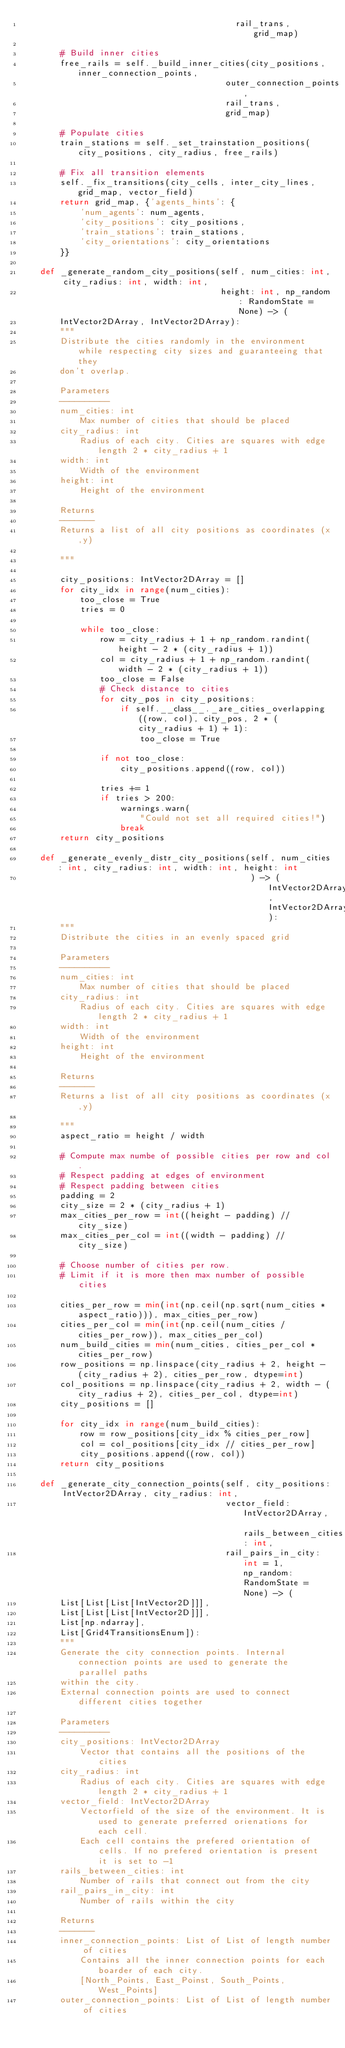<code> <loc_0><loc_0><loc_500><loc_500><_Python_>                                           rail_trans, grid_map)

        # Build inner cities
        free_rails = self._build_inner_cities(city_positions, inner_connection_points,
                                         outer_connection_points,
                                         rail_trans,
                                         grid_map)

        # Populate cities
        train_stations = self._set_trainstation_positions(city_positions, city_radius, free_rails)

        # Fix all transition elements
        self._fix_transitions(city_cells, inter_city_lines, grid_map, vector_field)
        return grid_map, {'agents_hints': {
            'num_agents': num_agents,
            'city_positions': city_positions,
            'train_stations': train_stations,
            'city_orientations': city_orientations
        }}

    def _generate_random_city_positions(self, num_cities: int, city_radius: int, width: int,
                                        height: int, np_random: RandomState = None) -> (
        IntVector2DArray, IntVector2DArray):
        """
        Distribute the cities randomly in the environment while respecting city sizes and guaranteeing that they
        don't overlap.

        Parameters
        ----------
        num_cities: int
            Max number of cities that should be placed
        city_radius: int
            Radius of each city. Cities are squares with edge length 2 * city_radius + 1
        width: int
            Width of the environment
        height: int
            Height of the environment

        Returns
        -------
        Returns a list of all city positions as coordinates (x,y)

        """

        city_positions: IntVector2DArray = []
        for city_idx in range(num_cities):
            too_close = True
            tries = 0

            while too_close:
                row = city_radius + 1 + np_random.randint(height - 2 * (city_radius + 1))
                col = city_radius + 1 + np_random.randint(width - 2 * (city_radius + 1))
                too_close = False
                # Check distance to cities
                for city_pos in city_positions:
                    if self.__class__._are_cities_overlapping((row, col), city_pos, 2 * (city_radius + 1) + 1):
                        too_close = True

                if not too_close:
                    city_positions.append((row, col))

                tries += 1
                if tries > 200:
                    warnings.warn(
                        "Could not set all required cities!")
                    break
        return city_positions

    def _generate_evenly_distr_city_positions(self, num_cities: int, city_radius: int, width: int, height: int
                                              ) -> (IntVector2DArray, IntVector2DArray):
        """
        Distribute the cities in an evenly spaced grid

        Parameters
        ----------
        num_cities: int
            Max number of cities that should be placed
        city_radius: int
            Radius of each city. Cities are squares with edge length 2 * city_radius + 1
        width: int
            Width of the environment
        height: int
            Height of the environment

        Returns
        -------
        Returns a list of all city positions as coordinates (x,y)

        """
        aspect_ratio = height / width

        # Compute max numbe of possible cities per row and col.
        # Respect padding at edges of environment
        # Respect padding between cities
        padding = 2
        city_size = 2 * (city_radius + 1)
        max_cities_per_row = int((height - padding) // city_size)
        max_cities_per_col = int((width - padding) // city_size)

        # Choose number of cities per row.
        # Limit if it is more then max number of possible cities

        cities_per_row = min(int(np.ceil(np.sqrt(num_cities * aspect_ratio))), max_cities_per_row)
        cities_per_col = min(int(np.ceil(num_cities / cities_per_row)), max_cities_per_col)
        num_build_cities = min(num_cities, cities_per_col * cities_per_row)
        row_positions = np.linspace(city_radius + 2, height - (city_radius + 2), cities_per_row, dtype=int)
        col_positions = np.linspace(city_radius + 2, width - (city_radius + 2), cities_per_col, dtype=int)
        city_positions = []

        for city_idx in range(num_build_cities):
            row = row_positions[city_idx % cities_per_row]
            col = col_positions[city_idx // cities_per_row]
            city_positions.append((row, col))
        return city_positions

    def _generate_city_connection_points(self, city_positions: IntVector2DArray, city_radius: int,
                                         vector_field: IntVector2DArray, rails_between_cities: int,
                                         rail_pairs_in_city: int = 1, np_random: RandomState = None) -> (
        List[List[List[IntVector2D]]],
        List[List[List[IntVector2D]]],
        List[np.ndarray],
        List[Grid4TransitionsEnum]):
        """
        Generate the city connection points. Internal connection points are used to generate the parallel paths
        within the city.
        External connection points are used to connect different cities together

        Parameters
        ----------
        city_positions: IntVector2DArray
            Vector that contains all the positions of the cities
        city_radius: int
            Radius of each city. Cities are squares with edge length 2 * city_radius + 1
        vector_field: IntVector2DArray
            Vectorfield of the size of the environment. It is used to generate preferred orienations for each cell.
            Each cell contains the prefered orientation of cells. If no prefered orientation is present it is set to -1
        rails_between_cities: int
            Number of rails that connect out from the city
        rail_pairs_in_city: int
            Number of rails within the city

        Returns
        -------
        inner_connection_points: List of List of length number of cities
            Contains all the inner connection points for each boarder of each city.
            [North_Points, East_Poinst, South_Points, West_Points]
        outer_connection_points: List of List of length number of cities</code> 